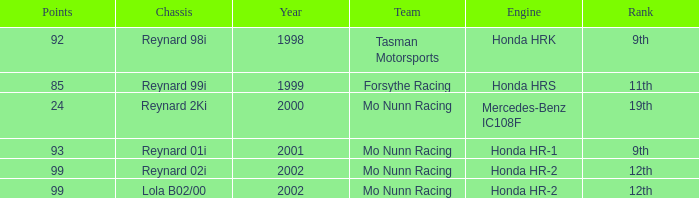What is the rank of the reynard 2ki chassis before 2002? 19th. 